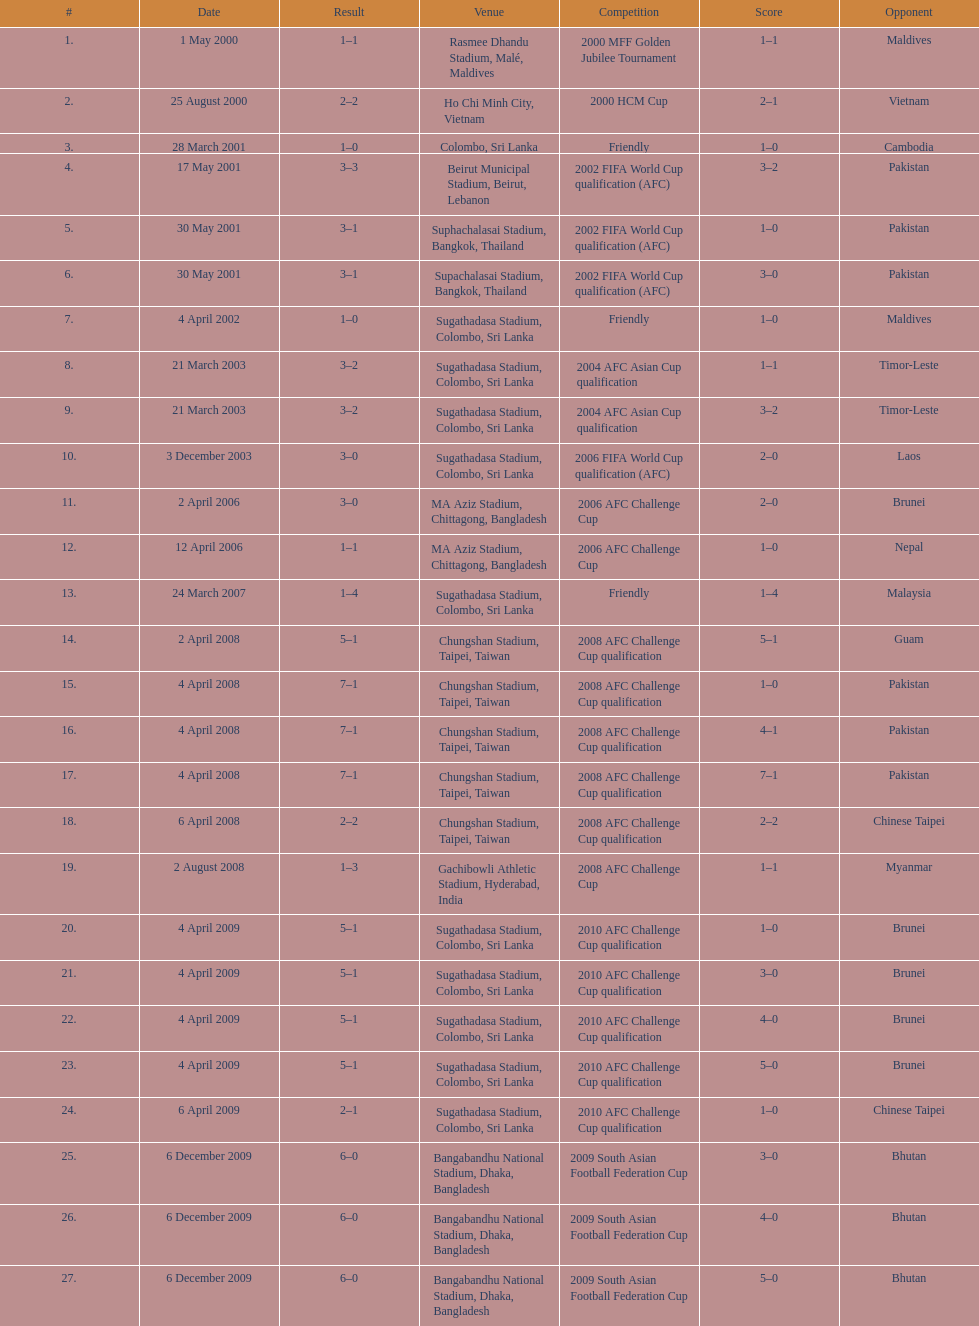Parse the full table. {'header': ['#', 'Date', 'Result', 'Venue', 'Competition', 'Score', 'Opponent'], 'rows': [['1.', '1 May 2000', '1–1', 'Rasmee Dhandu Stadium, Malé, Maldives', '2000 MFF Golden Jubilee Tournament', '1–1', 'Maldives'], ['2.', '25 August 2000', '2–2', 'Ho Chi Minh City, Vietnam', '2000 HCM Cup', '2–1', 'Vietnam'], ['3.', '28 March 2001', '1–0', 'Colombo, Sri Lanka', 'Friendly', '1–0', 'Cambodia'], ['4.', '17 May 2001', '3–3', 'Beirut Municipal Stadium, Beirut, Lebanon', '2002 FIFA World Cup qualification (AFC)', '3–2', 'Pakistan'], ['5.', '30 May 2001', '3–1', 'Suphachalasai Stadium, Bangkok, Thailand', '2002 FIFA World Cup qualification (AFC)', '1–0', 'Pakistan'], ['6.', '30 May 2001', '3–1', 'Supachalasai Stadium, Bangkok, Thailand', '2002 FIFA World Cup qualification (AFC)', '3–0', 'Pakistan'], ['7.', '4 April 2002', '1–0', 'Sugathadasa Stadium, Colombo, Sri Lanka', 'Friendly', '1–0', 'Maldives'], ['8.', '21 March 2003', '3–2', 'Sugathadasa Stadium, Colombo, Sri Lanka', '2004 AFC Asian Cup qualification', '1–1', 'Timor-Leste'], ['9.', '21 March 2003', '3–2', 'Sugathadasa Stadium, Colombo, Sri Lanka', '2004 AFC Asian Cup qualification', '3–2', 'Timor-Leste'], ['10.', '3 December 2003', '3–0', 'Sugathadasa Stadium, Colombo, Sri Lanka', '2006 FIFA World Cup qualification (AFC)', '2–0', 'Laos'], ['11.', '2 April 2006', '3–0', 'MA Aziz Stadium, Chittagong, Bangladesh', '2006 AFC Challenge Cup', '2–0', 'Brunei'], ['12.', '12 April 2006', '1–1', 'MA Aziz Stadium, Chittagong, Bangladesh', '2006 AFC Challenge Cup', '1–0', 'Nepal'], ['13.', '24 March 2007', '1–4', 'Sugathadasa Stadium, Colombo, Sri Lanka', 'Friendly', '1–4', 'Malaysia'], ['14.', '2 April 2008', '5–1', 'Chungshan Stadium, Taipei, Taiwan', '2008 AFC Challenge Cup qualification', '5–1', 'Guam'], ['15.', '4 April 2008', '7–1', 'Chungshan Stadium, Taipei, Taiwan', '2008 AFC Challenge Cup qualification', '1–0', 'Pakistan'], ['16.', '4 April 2008', '7–1', 'Chungshan Stadium, Taipei, Taiwan', '2008 AFC Challenge Cup qualification', '4–1', 'Pakistan'], ['17.', '4 April 2008', '7–1', 'Chungshan Stadium, Taipei, Taiwan', '2008 AFC Challenge Cup qualification', '7–1', 'Pakistan'], ['18.', '6 April 2008', '2–2', 'Chungshan Stadium, Taipei, Taiwan', '2008 AFC Challenge Cup qualification', '2–2', 'Chinese Taipei'], ['19.', '2 August 2008', '1–3', 'Gachibowli Athletic Stadium, Hyderabad, India', '2008 AFC Challenge Cup', '1–1', 'Myanmar'], ['20.', '4 April 2009', '5–1', 'Sugathadasa Stadium, Colombo, Sri Lanka', '2010 AFC Challenge Cup qualification', '1–0', 'Brunei'], ['21.', '4 April 2009', '5–1', 'Sugathadasa Stadium, Colombo, Sri Lanka', '2010 AFC Challenge Cup qualification', '3–0', 'Brunei'], ['22.', '4 April 2009', '5–1', 'Sugathadasa Stadium, Colombo, Sri Lanka', '2010 AFC Challenge Cup qualification', '4–0', 'Brunei'], ['23.', '4 April 2009', '5–1', 'Sugathadasa Stadium, Colombo, Sri Lanka', '2010 AFC Challenge Cup qualification', '5–0', 'Brunei'], ['24.', '6 April 2009', '2–1', 'Sugathadasa Stadium, Colombo, Sri Lanka', '2010 AFC Challenge Cup qualification', '1–0', 'Chinese Taipei'], ['25.', '6 December 2009', '6–0', 'Bangabandhu National Stadium, Dhaka, Bangladesh', '2009 South Asian Football Federation Cup', '3–0', 'Bhutan'], ['26.', '6 December 2009', '6–0', 'Bangabandhu National Stadium, Dhaka, Bangladesh', '2009 South Asian Football Federation Cup', '4–0', 'Bhutan'], ['27.', '6 December 2009', '6–0', 'Bangabandhu National Stadium, Dhaka, Bangladesh', '2009 South Asian Football Federation Cup', '5–0', 'Bhutan']]} What is the top listed venue in the table? Rasmee Dhandu Stadium, Malé, Maldives. 